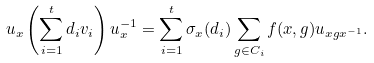<formula> <loc_0><loc_0><loc_500><loc_500>u _ { x } \left ( \sum _ { i = 1 } ^ { t } d _ { i } v _ { i } \right ) u _ { x } ^ { - 1 } = \sum _ { i = 1 } ^ { t } \sigma _ { x } ( d _ { i } ) \sum _ { g \in C _ { i } } f ( x , g ) u _ { x g x ^ { - 1 } } .</formula> 